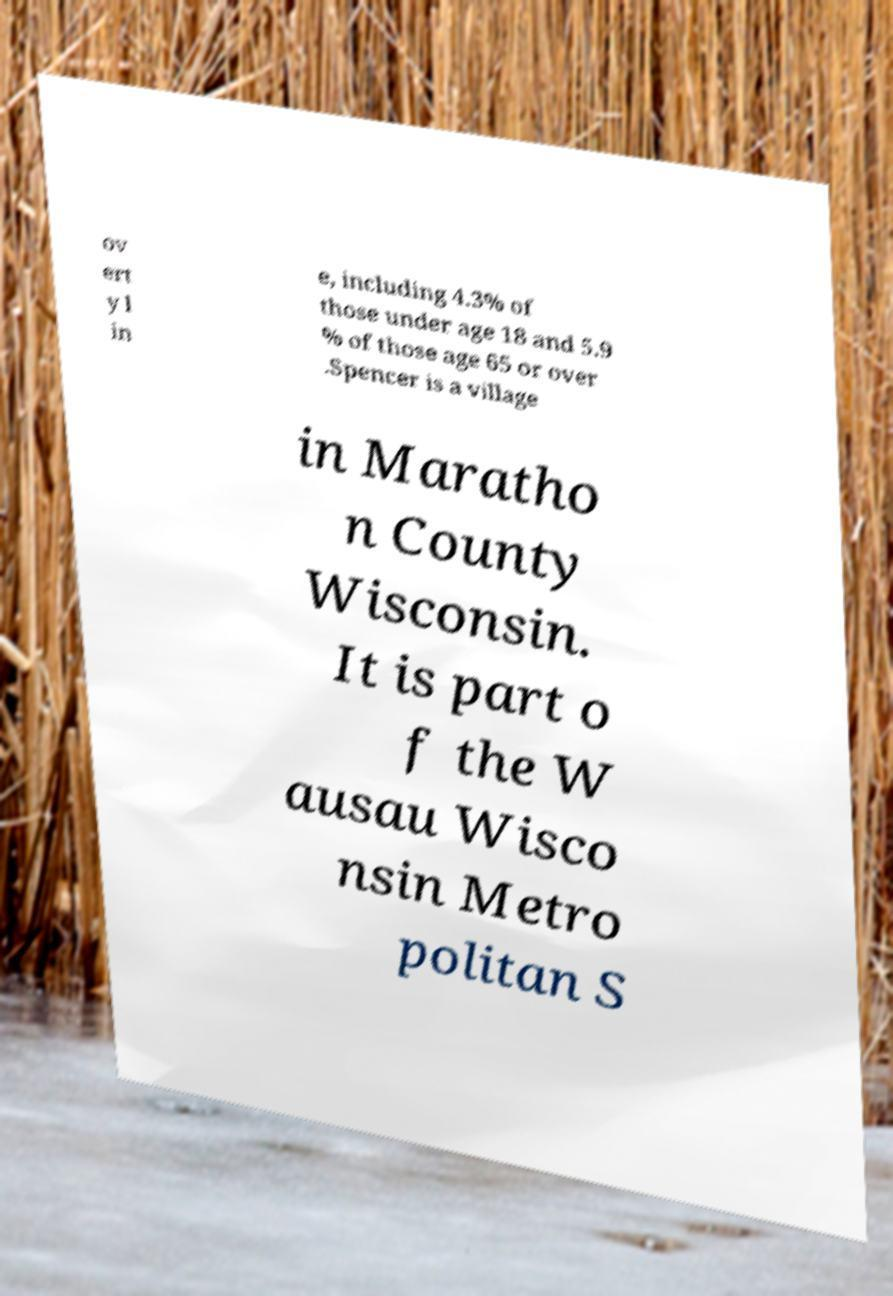What messages or text are displayed in this image? I need them in a readable, typed format. ov ert y l in e, including 4.3% of those under age 18 and 5.9 % of those age 65 or over .Spencer is a village in Maratho n County Wisconsin. It is part o f the W ausau Wisco nsin Metro politan S 